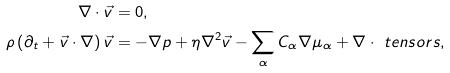Convert formula to latex. <formula><loc_0><loc_0><loc_500><loc_500>\nabla \cdot \vec { v } & = 0 , \\ \rho \left ( \partial _ { t } + \vec { v } \cdot \nabla \right ) \vec { v } & = - \nabla p + \eta \nabla ^ { 2 } \vec { v } - \sum _ { \alpha } C _ { \alpha } \nabla \mu _ { \alpha } + \nabla \cdot \ t e n s o r { s } ,</formula> 